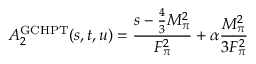Convert formula to latex. <formula><loc_0><loc_0><loc_500><loc_500>A _ { 2 } ^ { G C H P T } ( s , t , u ) = \frac { s - \frac { 4 } { 3 } M _ { \pi } ^ { 2 } } { F _ { \pi } ^ { 2 } } + \alpha \frac { M _ { \pi } ^ { 2 } } { 3 F _ { \pi } ^ { 2 } }</formula> 